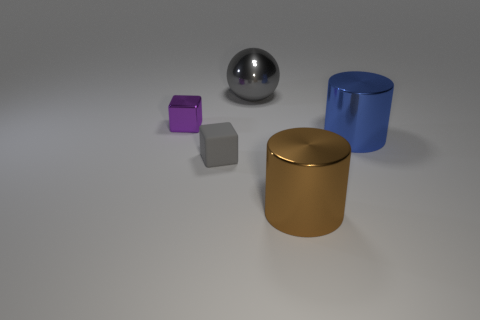There is another thing that is the same shape as the big brown shiny thing; what color is it?
Offer a very short reply. Blue. There is a rubber object; is it the same color as the shiny object left of the big gray thing?
Give a very brief answer. No. The large thing that is both in front of the small metal thing and left of the large blue thing has what shape?
Your response must be concise. Cylinder. Is the number of large gray balls less than the number of big red matte cylinders?
Provide a short and direct response. No. Are any cylinders visible?
Your answer should be very brief. Yes. What number of other objects are there of the same size as the brown thing?
Keep it short and to the point. 2. Is the sphere made of the same material as the gray object that is left of the large gray metal object?
Your answer should be very brief. No. Are there an equal number of blue cylinders that are to the left of the large brown metallic object and large brown metal cylinders that are in front of the gray metallic sphere?
Your answer should be very brief. No. What is the material of the gray block?
Give a very brief answer. Rubber. The metallic sphere that is the same size as the blue metallic cylinder is what color?
Provide a short and direct response. Gray. 